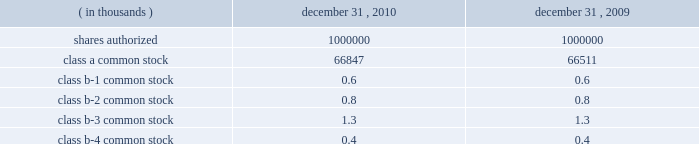Interest rate derivatives .
In connection with the issuance of floating rate debt in august and october 2008 , the company entered into three interest rate swap contracts , designated as cash flow hedges , for purposes of hedging against a change in interest payments due to fluctuations in the underlying benchmark rate .
In december 2010 , the company approved a plan to refinance the term loan in january 2011 resulting in an $ 8.6 million loss on derivative instruments as a result of ineffectiveness on the associated interest rate swap contract .
To mitigate counterparty credit risk , the interest rate swap contracts required collateralization by both counterparties for the swaps 2019 aggregate net fair value during their respective terms .
Collateral was maintained in the form of cash and adjusted on a daily basis .
In february 2010 , the company entered into a forward starting interest rate swap contract , designated as a cash flow hedge , for purposes of hedging against a change in interest payments due to fluctuations in the underlying benchmark rate between the date of the swap and the forecasted issuance of fixed rate debt in march 2010 .
The swap was highly effective .
Foreign currency derivatives .
In connection with its purchase of bm&fbovespa stock in february 2008 , cme group purchased a put option to hedge against changes in the fair value of bm&fbovespa stock resulting from foreign currency rate fluctuations between the u.s .
Dollar and the brazilian real ( brl ) beyond the option 2019s exercise price .
Lehman brothers special financing inc .
( lbsf ) was the sole counterparty to this option contract .
On september 15 , 2008 , lehman brothers holdings inc .
( lehman ) filed for protection under chapter 11 of the united states bankruptcy code .
The bankruptcy filing of lehman was an event of default that gave the company the right to immediately terminate the put option agreement with lbsf .
In march 2010 , the company recognized a $ 6.0 million gain on derivative instruments as a result of a settlement from the lehman bankruptcy proceedings .
21 .
Capital stock shares outstanding .
The table presents information regarding capital stock: .
Cme group has no shares of preferred stock issued and outstanding .
Associated trading rights .
Members of cme , cbot , nymex and comex own or lease trading rights which entitle them to access the trading floors , discounts on trading fees and the right to vote on certain exchange matters as provided for by the rules of the particular exchange and cme group 2019s or the subsidiaries 2019 organizational documents .
Each class of cme group class b common stock is associated with a membership in a specific division for trading at cme .
A cme trading right is a separate asset that is not part of or evidenced by the associated share of class b common stock of cme group .
The class b common stock of cme group is intended only to ensure that the class b shareholders of cme group retain rights with respect to representation on the board of directors and approval rights with respect to the core rights described below .
Trading rights at cbot are evidenced by class b memberships in cbot , at nymex by class a memberships in nymex and at comex by comex division memberships in comex .
Members of the cbot , nymex and comex exchanges do not have any rights to elect members of the board of directors and are not entitled to receive dividends or other distributions on their memberships .
The company is , however , required to have at least 10 cbot directors ( as defined by its bylaws ) until its 2012 annual meeting. .
In thousands , what was the average number of shares of class a common stock outstanding? 
Computations: table_average(class a common stock, none)
Answer: 66679.0. 